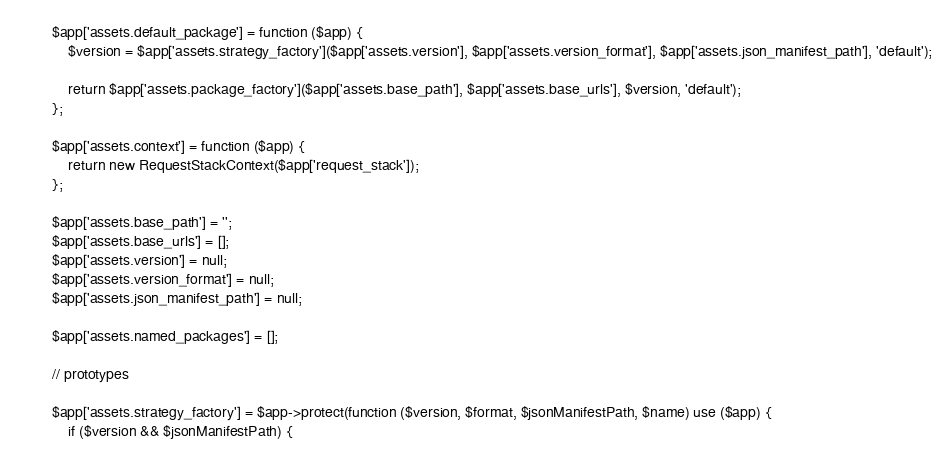Convert code to text. <code><loc_0><loc_0><loc_500><loc_500><_PHP_>        $app['assets.default_package'] = function ($app) {
            $version = $app['assets.strategy_factory']($app['assets.version'], $app['assets.version_format'], $app['assets.json_manifest_path'], 'default');

            return $app['assets.package_factory']($app['assets.base_path'], $app['assets.base_urls'], $version, 'default');
        };

        $app['assets.context'] = function ($app) {
            return new RequestStackContext($app['request_stack']);
        };

        $app['assets.base_path'] = '';
        $app['assets.base_urls'] = [];
        $app['assets.version'] = null;
        $app['assets.version_format'] = null;
        $app['assets.json_manifest_path'] = null;

        $app['assets.named_packages'] = [];

        // prototypes

        $app['assets.strategy_factory'] = $app->protect(function ($version, $format, $jsonManifestPath, $name) use ($app) {
            if ($version && $jsonManifestPath) {</code> 